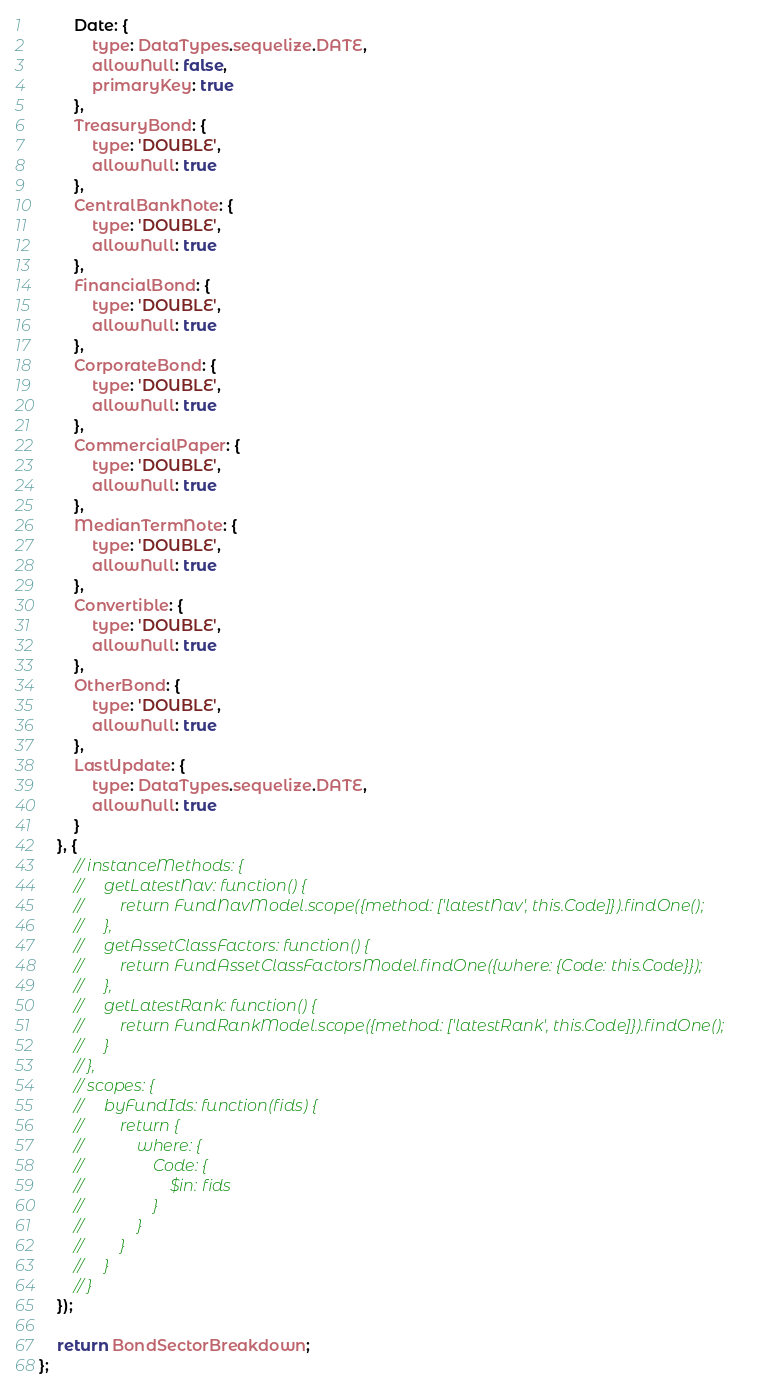<code> <loc_0><loc_0><loc_500><loc_500><_JavaScript_>        Date: {
            type: DataTypes.sequelize.DATE,
            allowNull: false,
            primaryKey: true
        },
        TreasuryBond: {
            type: 'DOUBLE',
            allowNull: true
        },
        CentralBankNote: {
            type: 'DOUBLE',
            allowNull: true
        },
        FinancialBond: {
            type: 'DOUBLE',
            allowNull: true
        },
        CorporateBond: {
            type: 'DOUBLE',
            allowNull: true
        },
        CommercialPaper: {
            type: 'DOUBLE',
            allowNull: true
        },
        MedianTermNote: {
            type: 'DOUBLE',
            allowNull: true
        },
        Convertible: {
            type: 'DOUBLE',
            allowNull: true
        },
        OtherBond: {
            type: 'DOUBLE',
            allowNull: true
        },
        LastUpdate: {
            type: DataTypes.sequelize.DATE,
            allowNull: true
        }
    }, {
        // instanceMethods: {
        //     getLatestNav: function() {
        //         return FundNavModel.scope({method: ['latestNav', this.Code]}).findOne();
        //     },
        //     getAssetClassFactors: function() {
        //         return FundAssetClassFactorsModel.findOne({where: {Code: this.Code}});
        //     },
        //     getLatestRank: function() {
        //         return FundRankModel.scope({method: ['latestRank', this.Code]}).findOne();
        //     }
        // },
        // scopes: {
        //     byFundIds: function(fids) {
        //         return {
        //             where: {
        //                 Code: {
        //                     $in: fids
        //                 }
        //             }
        //         }
        //     }
        // }
    });

    return BondSectorBreakdown;
};
</code> 